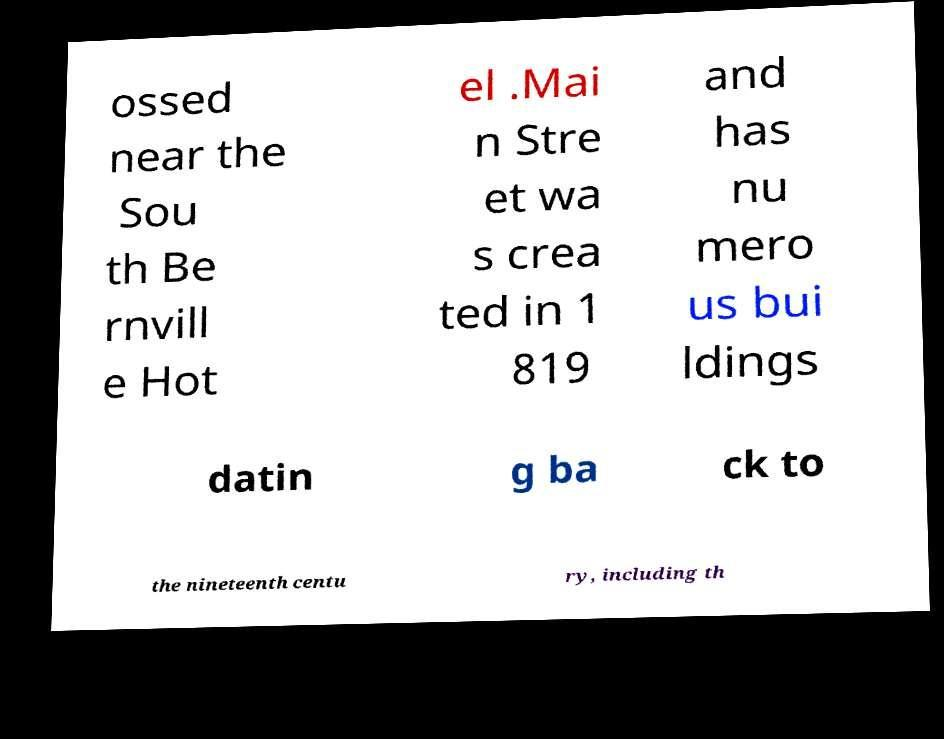Please read and relay the text visible in this image. What does it say? ossed near the Sou th Be rnvill e Hot el .Mai n Stre et wa s crea ted in 1 819 and has nu mero us bui ldings datin g ba ck to the nineteenth centu ry, including th 